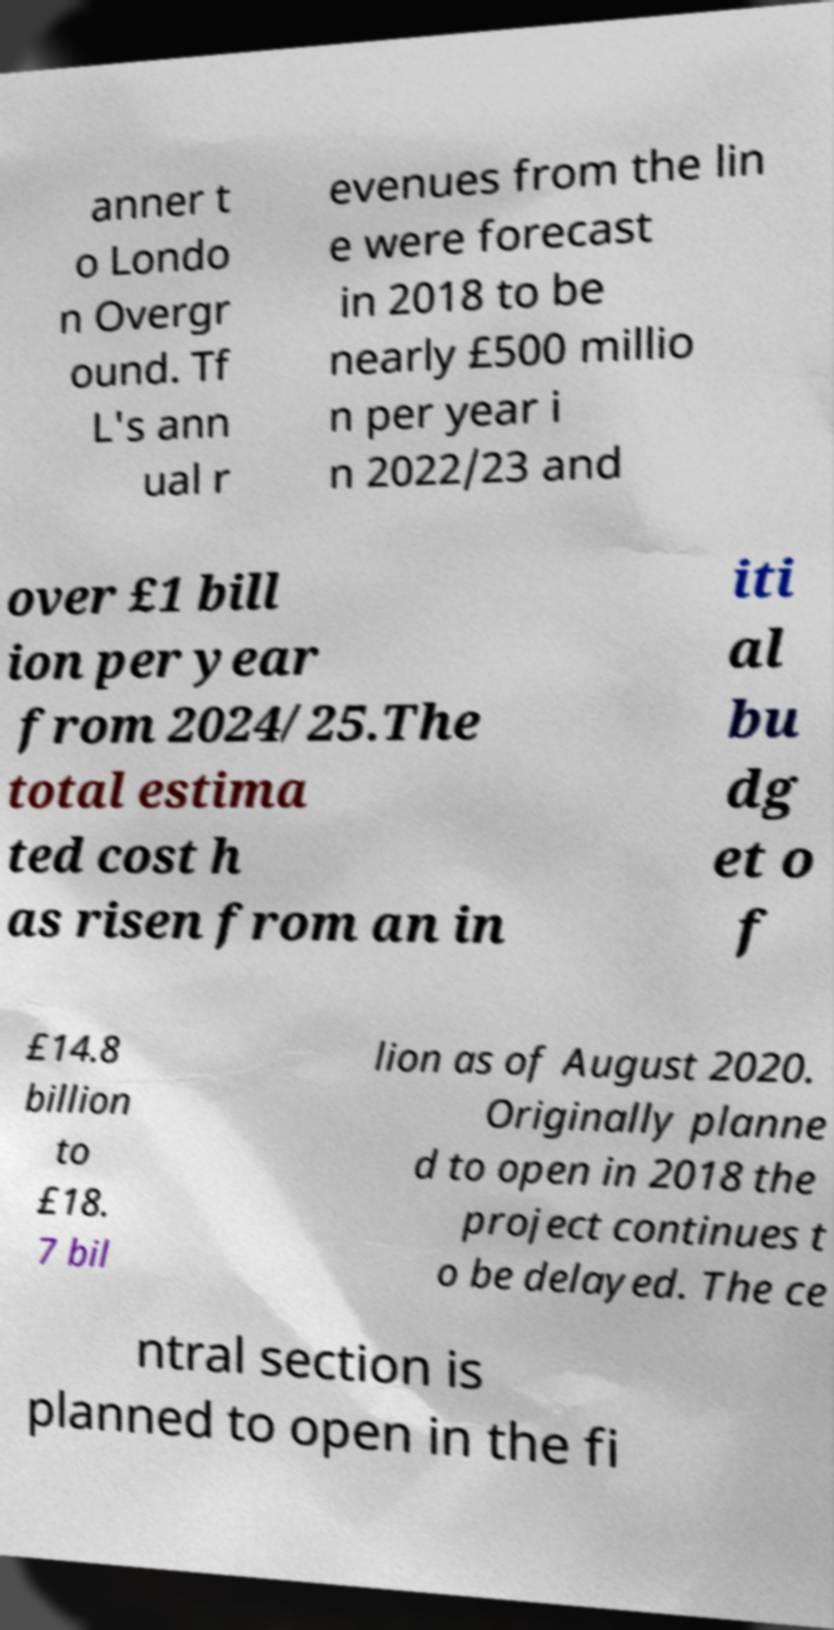What messages or text are displayed in this image? I need them in a readable, typed format. anner t o Londo n Overgr ound. Tf L's ann ual r evenues from the lin e were forecast in 2018 to be nearly £500 millio n per year i n 2022/23 and over £1 bill ion per year from 2024/25.The total estima ted cost h as risen from an in iti al bu dg et o f £14.8 billion to £18. 7 bil lion as of August 2020. Originally planne d to open in 2018 the project continues t o be delayed. The ce ntral section is planned to open in the fi 